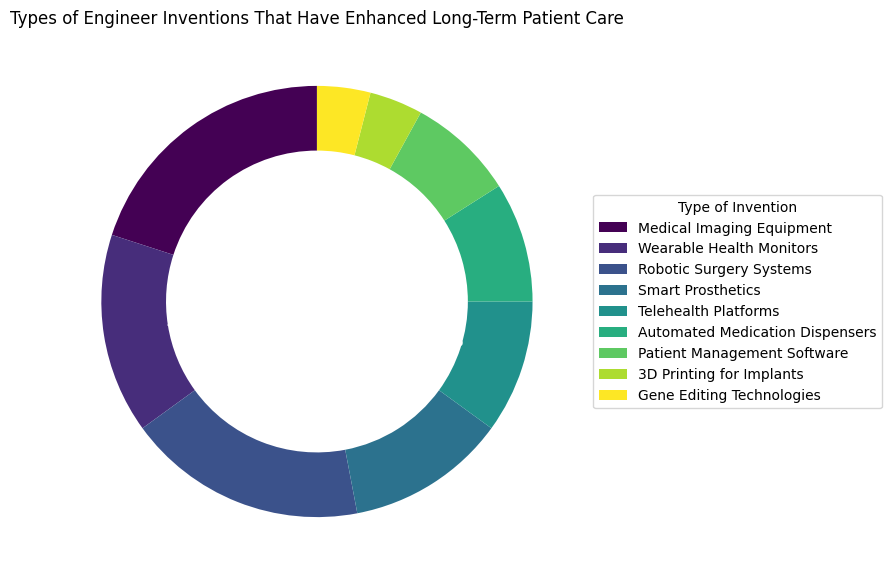What percentage of inventions are related to direct patient monitoring (including Wearable Health Monitors and Telehealth Platforms)? To find the percentage of inventions related to direct patient monitoring, sum the percentages for Wearable Health Monitors (15%) and Telehealth Platforms (10%). So, 15 + 10 = 25.
Answer: 25% Which invention type has the highest percentage, and what is that percentage? Look at the pie chart and identify the largest slice. The largest slice corresponds to Medical Imaging Equipment, which has a percentage of 20%.
Answer: Medical Imaging Equipment, 20% Are there more inventions related to Advanced Medical Equipment (Medical Imaging Equipment, Robotic Surgery Systems, Smart Prosthetics) or Software Solutions (Telehealth Platforms, Patient Management Software)? Sum the percentages for Advanced Medical Equipment: Medical Imaging Equipment (20%) + Robotic Surgery Systems (18%) + Smart Prosthetics (12%) = 50. Sum the percentages for Software Solutions: Telehealth Platforms (10%) + Patient Management Software (8%) = 18. Compare 50% and 18%.
Answer: Advanced Medical Equipment, 50% Which category has a lower percentage: Gene Editing Technologies or Automated Medication Dispensers? Compare the slices for Gene Editing Technologies (4%) and Automated Medication Dispensers (9%). Gene Editing Technologies has a lower percentage.
Answer: Gene Editing Technologies, 4% What is the combined percentage of inventions related to Automated Medication Dispensers and Patient Management Software? Add the percentages for Automated Medication Dispensers (9%) and Patient Management Software (8%). So, 9 + 8 = 17%.
Answer: 17% Which invention type has a percentage closest to the average percentage of all the invention types? First, calculate the average percentage of all invention types: (20 + 15 + 18 + 12 + 10 + 9 + 8 + 4 + 4) / 9 = 11.11%. Find the invention type with the closest percentage to 11.11%, which is Smart Prosthetics at 12%.
Answer: Smart Prosthetics, 12% How many invention types have a percentage greater than 10%? Count the slices with percentages greater than 10%. These are Medical Imaging Equipment (20%), Wearable Health Monitors (15%), Robotic Surgery Systems (18%), and Smart Prosthetics (12%). There are 4 such invention types.
Answer: 4 What is the percentage difference between the highest and lowest types of inventions? Identify the highest percentage (Medical Imaging Equipment, 20%) and the lowest percentage (Gene Editing Technologies and 3D Printing for Implants, 4%). Subtract the lowest from the highest: 20 - 4 = 16%.
Answer: 16% 